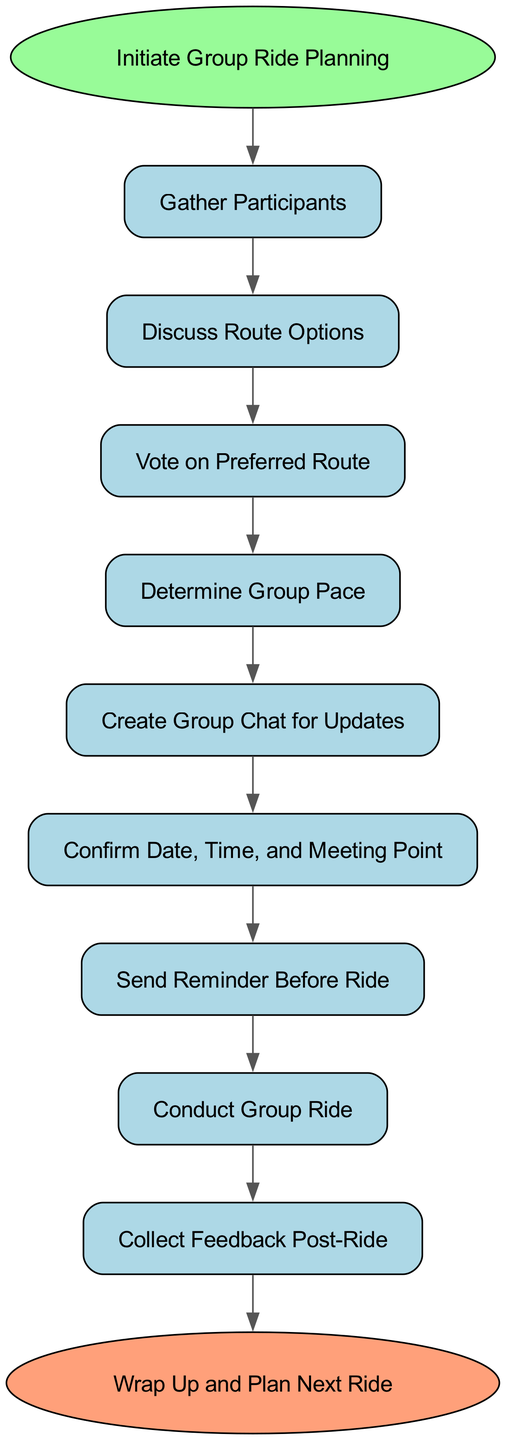What is the first step in the group ride planning process? The diagram starts with the node labeled "Initiate Group Ride Planning," which indicates that this is the first action to take.
Answer: Initiate Group Ride Planning How many steps are there in the group ride coordination flowchart? By counting the nodes in the diagram, there are a total of 10 steps from start to end.
Answer: 10 What step follows "Discuss Route Options"? The connection in the diagram shows that after "Discuss Route Options," the next step is "Vote on Preferred Route."
Answer: Vote on Preferred Route What color represents the starting point of the diagram? The starting point, labeled "Initiate Group Ride Planning," is represented with a green color (light green).
Answer: Light green Which step comes before "Send Reminder Before Ride"? The diagram illustrates that "Confirm Date, Time, and Meeting Point" is the step that precedes "Send Reminder Before Ride."
Answer: Confirm Date, Time, and Meeting Point What is the last action taken in the group ride planning process? The final action in the diagram is marked by the node "Wrap Up and Plan Next Ride," indicating it is the concluding step of the process.
Answer: Wrap Up and Plan Next Ride What is the relationship between "Vote on Preferred Route" and "Determine Group Pace"? The diagram shows a directional connection from "Vote on Preferred Route" to "Determine Group Pace," indicating that the pace is set after the route has been chosen.
Answer: Directional connection What node represents the communication aspect of the ride planning? The node labeled "Create Group Chat for Updates" represents the communication aspect of the ride planning process.
Answer: Create Group Chat for Updates 